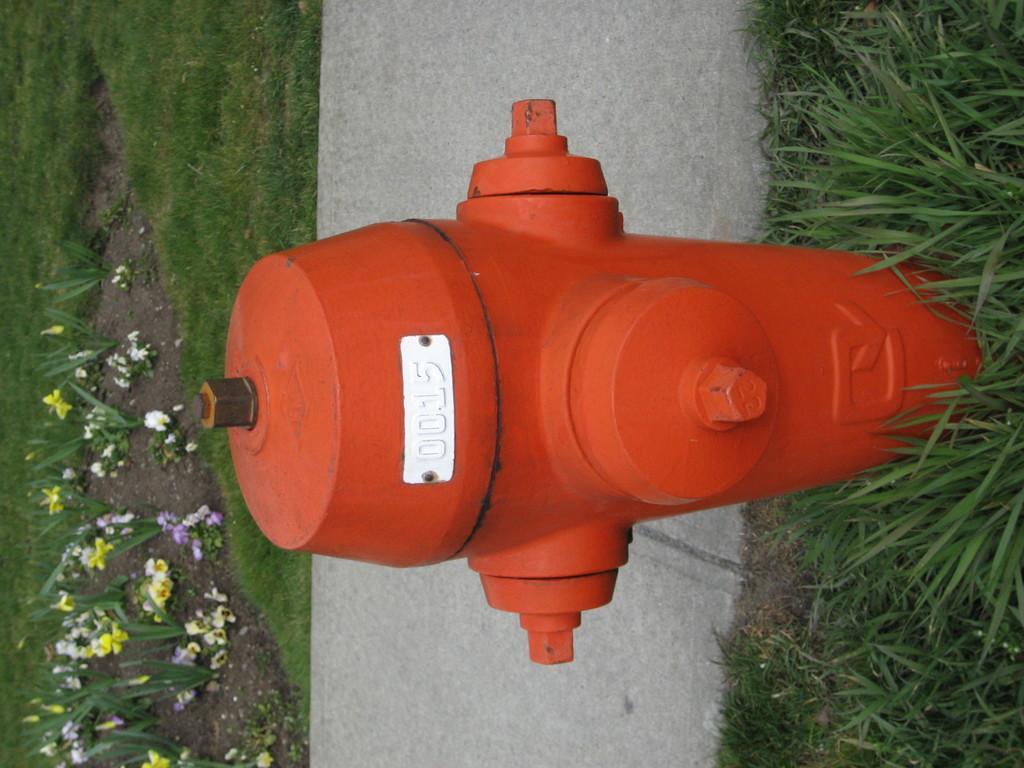How would you summarize this image in a sentence or two? In this picture I can see there is a fire hydrant and it is in orange color, there is a number on it. There is grass on the floor, behind the fire hydrant I can see there is a walkway and there is some grass, plants with flowers. 